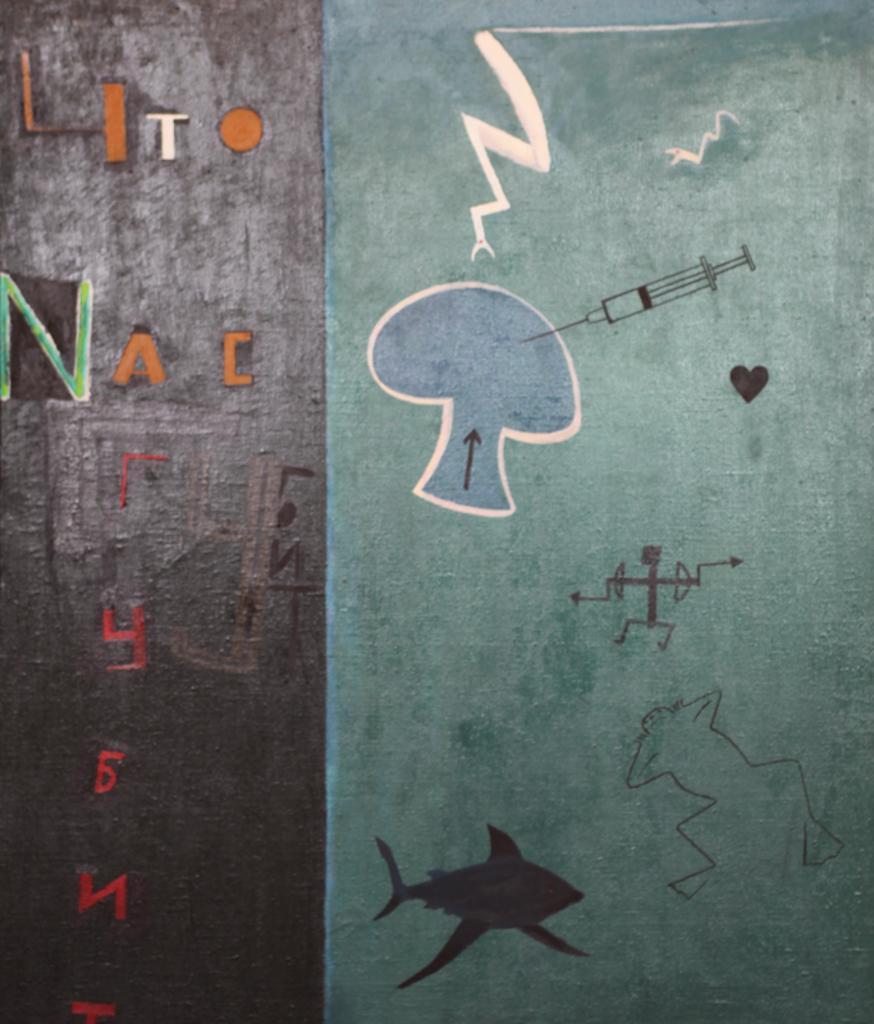What type of artwork is visible in the image? There are paintings in the image. What else can be seen on the wall in the image? There is text on the wall in the image. How many cars are parked in front of the paintings in the image? There are no cars visible in the image; it only features paintings and text on the wall. What shape are the girls in the image? There are no girls present in the image. 